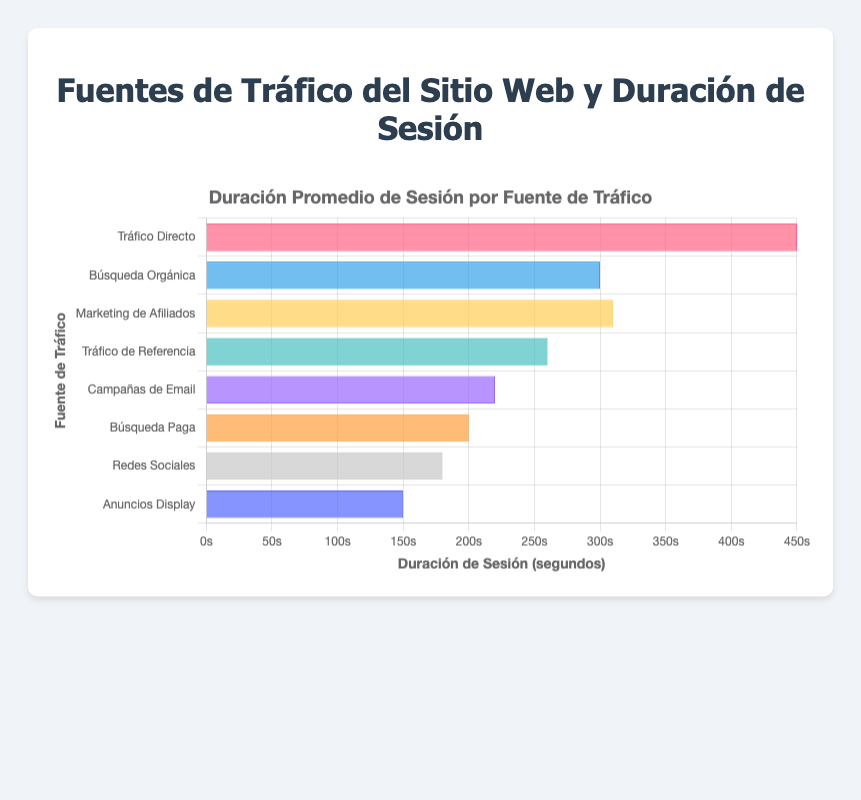What is the average session duration for Direct Traffic? According to the bar chart, the average session duration for Direct Traffic is represented by the bar labeled "Tráfico Directo", which has a value of 450 seconds.
Answer: 450 seconds Which traffic source has the longest average session duration? By observing the lengths of the bars, it is clear that "Tráfico Directo" (Direct Traffic) has the longest bar, indicating the longest average session duration.
Answer: Direct Traffic How does the average session duration of Organic Search compare to Social Media? Organic Search ("Búsqueda Orgánica") has an average session duration of 300 seconds, while Social Media ("Redes Sociales") has 180 seconds. Organic Search's duration is 300 - 180 = 120 seconds longer than Social Media.
Answer: Organic Search is longer by 120 seconds What is the total average session duration for Paid Search, Email Campaigns, and Display Ads? Paid Search ("Búsqueda Paga") has 200 seconds, Email Campaigns ("Campañas de Email") has 220 seconds, and Display Ads ("Anuncios Display") has 150 seconds. Summing these gives 200 + 220 + 150 = 570 seconds.
Answer: 570 seconds Which traffic sources have an average session duration less than 200 seconds? Social Media ("Redes Sociales") has 180 seconds and Display Ads ("Anuncios Display") has 150 seconds, both of which are less than 200 seconds.
Answer: Social Media, Display Ads What is the difference in average session duration between the highest and lowest traffic sources? The highest average session duration is for Direct Traffic at 450 seconds, and the lowest is for Display Ads at 150 seconds. The difference is 450 - 150 = 300 seconds.
Answer: 300 seconds What is the average session duration for sources labeled with colors other than red and blue? The sources other than red (Direct Traffic) and blue (Organic Search) are Affiliate Marketing, Referral Traffic, Email Campaigns, Paid Search, Social Media, and Display Ads. Their durations are 310, 260, 220, 200, 180, and 150 seconds respectively. The average is (310 + 260 + 220 + 200 + 180 + 150) / 6 = 220 seconds.
Answer: 220 seconds Which two traffic sources have the closest average session durations? Affiliate Marketing ("Marketing de Afiliados") has 310 seconds, and Organic Search ("Búsqueda Orgánica") has 300 seconds, with a difference of 10 seconds, the smallest difference among all sources.
Answer: Affiliate Marketing and Organic Search How many traffic sources have an average session duration greater than the average of the chart? First, calculate the overall average: (450 + 300 + 310 + 260 + 220 + 200 + 180 + 150) / 8 = 259.375 seconds. The sources above this average are Direct Traffic, Affiliate Marketing, Organic Search, and Referral Traffic.
Answer: 4 sources 